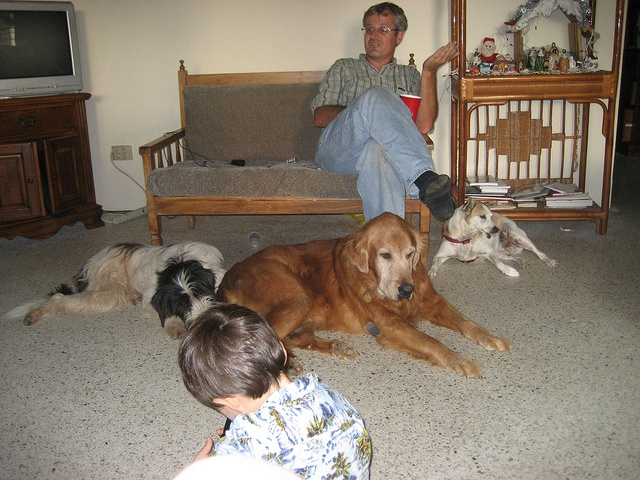Describe the objects in this image and their specific colors. I can see couch in black, gray, maroon, and brown tones, dog in black, maroon, gray, and brown tones, people in black, white, gray, and darkgray tones, people in black, darkgray, gray, and brown tones, and dog in black and gray tones in this image. 